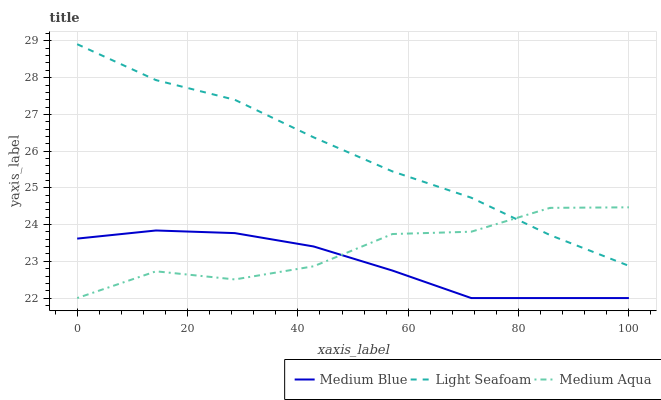Does Medium Blue have the minimum area under the curve?
Answer yes or no. Yes. Does Light Seafoam have the maximum area under the curve?
Answer yes or no. Yes. Does Light Seafoam have the minimum area under the curve?
Answer yes or no. No. Does Medium Blue have the maximum area under the curve?
Answer yes or no. No. Is Medium Blue the smoothest?
Answer yes or no. Yes. Is Medium Aqua the roughest?
Answer yes or no. Yes. Is Light Seafoam the smoothest?
Answer yes or no. No. Is Light Seafoam the roughest?
Answer yes or no. No. Does Medium Aqua have the lowest value?
Answer yes or no. Yes. Does Light Seafoam have the lowest value?
Answer yes or no. No. Does Light Seafoam have the highest value?
Answer yes or no. Yes. Does Medium Blue have the highest value?
Answer yes or no. No. Is Medium Blue less than Light Seafoam?
Answer yes or no. Yes. Is Light Seafoam greater than Medium Blue?
Answer yes or no. Yes. Does Medium Aqua intersect Medium Blue?
Answer yes or no. Yes. Is Medium Aqua less than Medium Blue?
Answer yes or no. No. Is Medium Aqua greater than Medium Blue?
Answer yes or no. No. Does Medium Blue intersect Light Seafoam?
Answer yes or no. No. 